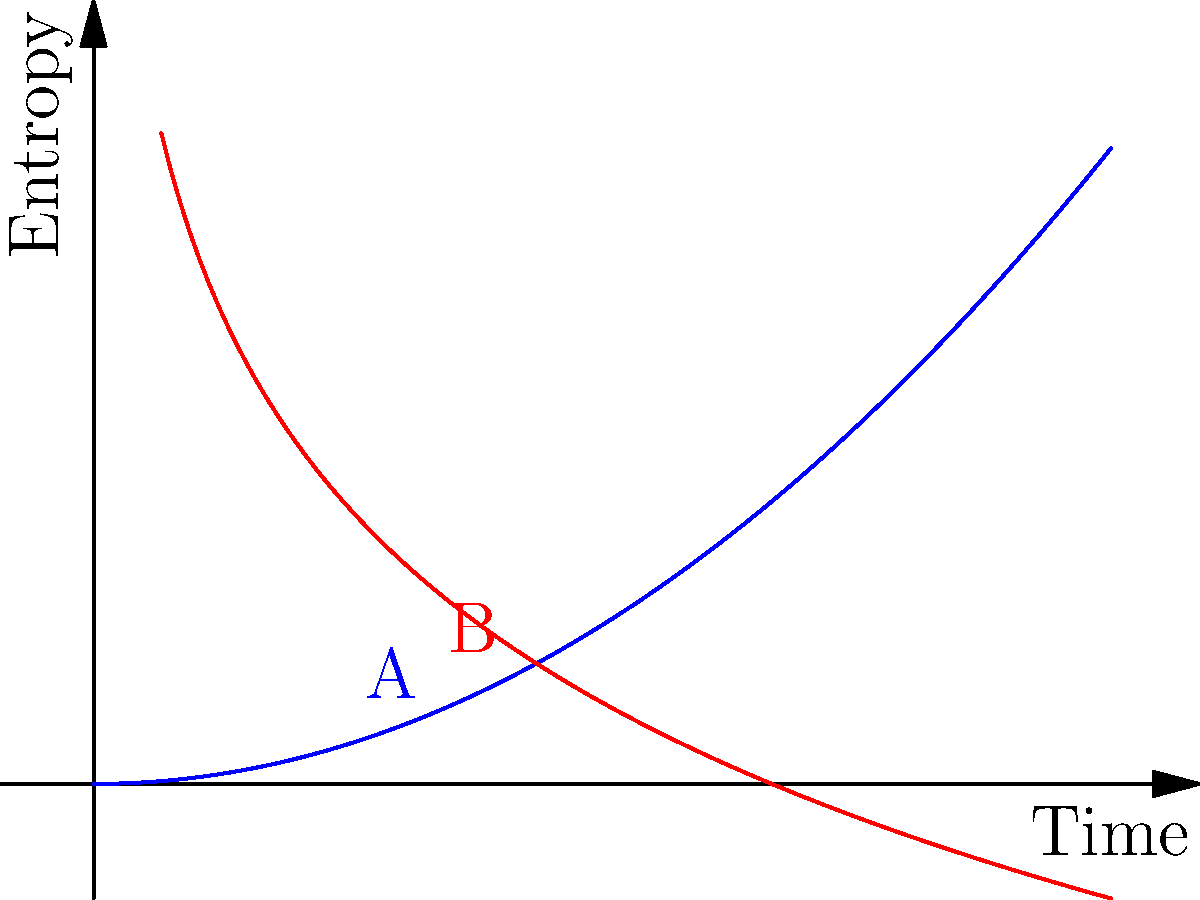The graph above illustrates the relationship between entropy and time for a closed system (blue curve A) and living organisms (red curve B). According to the Second Law of Thermodynamics, how can the apparent decrease in entropy for living organisms be reconciled with the overall increase in entropy of the universe? How does this relate to the origin of life? 1. The Second Law of Thermodynamics states that the entropy of a closed system always increases over time.

2. The blue curve (A) represents this principle, showing increasing disorder in a closed system.

3. However, the red curve (B) seems to contradict this law, showing decreasing entropy (increasing order) for living organisms.

4. This apparent contradiction can be reconciled by considering that living organisms are not closed systems. They interact with their environment, exchanging matter and energy.

5. Living organisms maintain their order by increasing the entropy of their surroundings. They take in low-entropy energy (e.g., food, sunlight) and release high-entropy waste.

6. The total entropy of the organism plus its environment still increases, satisfying the Second Law.

7. Regarding the origin of life, this principle presents a challenge. The formation of complex, ordered biological molecules from simpler components would require a local decrease in entropy.

8. This decrease must be compensated by an even greater increase in the entropy of the surrounding environment.

9. Some argue that this requirement for an external source of order makes the spontaneous origin of life thermodynamically improbable without the intervention of an intelligent designer.

10. Others contend that while unlikely, such local decreases in entropy are possible given the right conditions and sufficient time, especially considering the vast energy input from the sun and the chemical potential of the early Earth.
Answer: Local entropy decrease in living systems is offset by greater entropy increase in surroundings, challenging but not necessarily precluding naturalistic abiogenesis. 